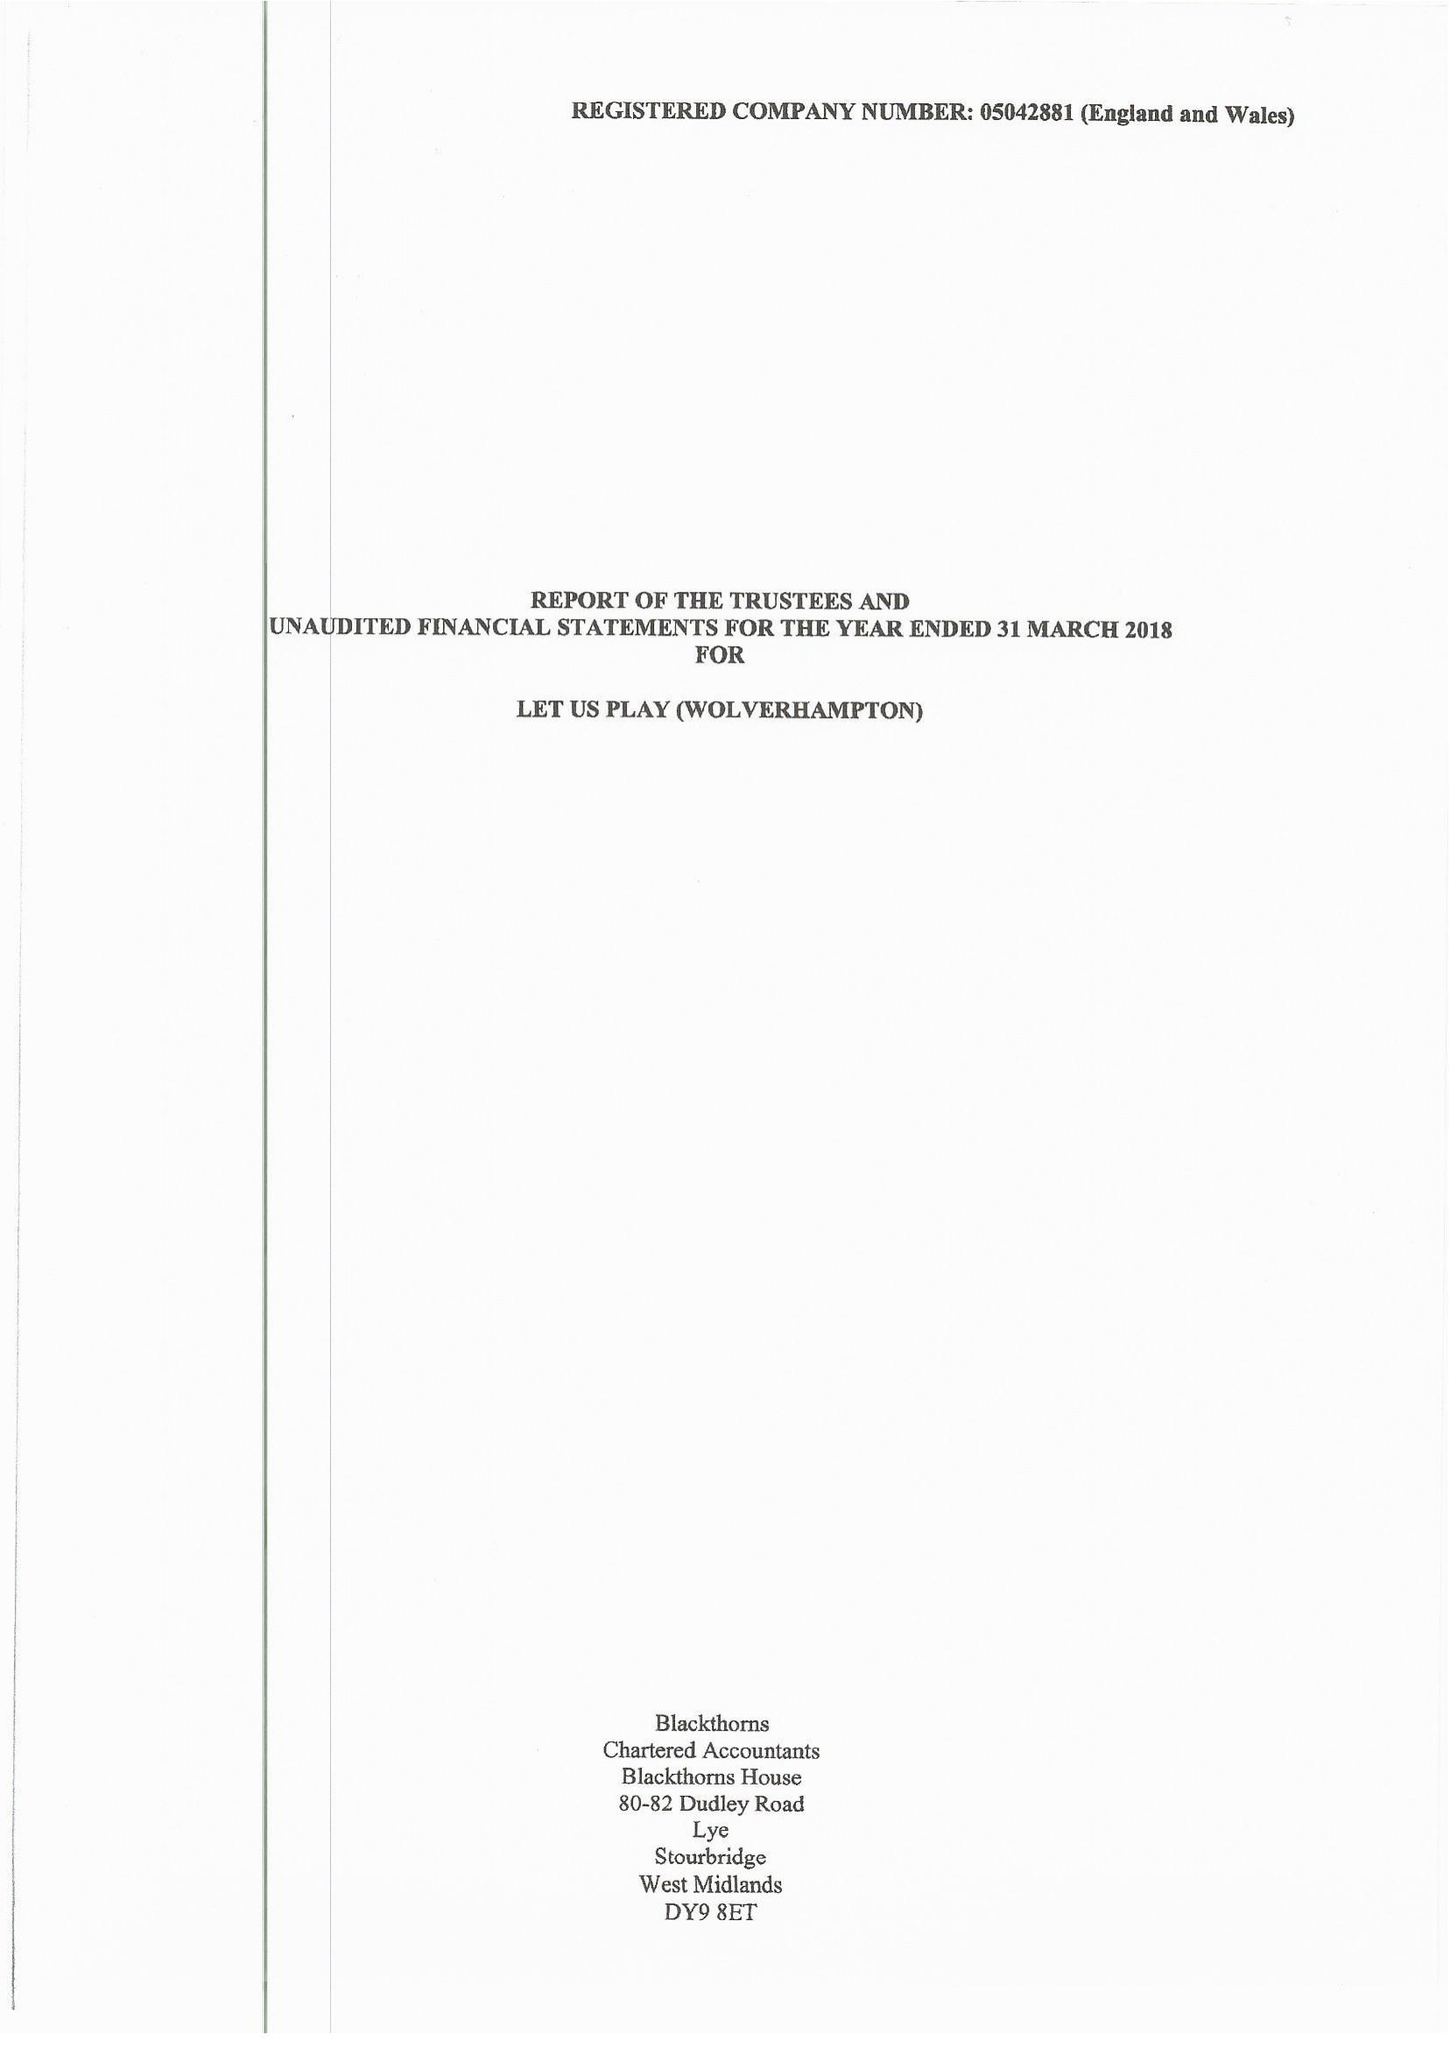What is the value for the report_date?
Answer the question using a single word or phrase. 2018-03-31 